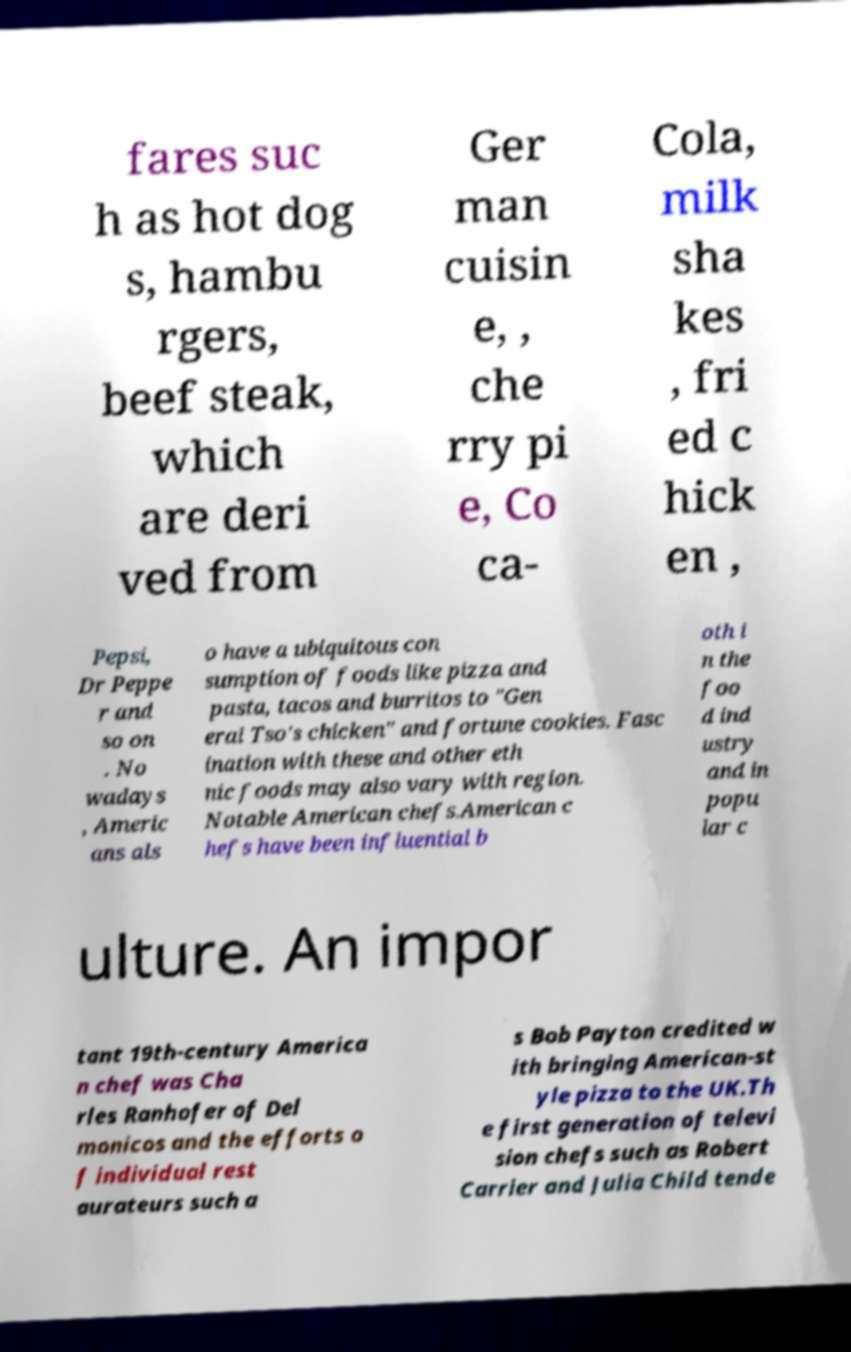Please read and relay the text visible in this image. What does it say? fares suc h as hot dog s, hambu rgers, beef steak, which are deri ved from Ger man cuisin e, , che rry pi e, Co ca- Cola, milk sha kes , fri ed c hick en , Pepsi, Dr Peppe r and so on . No wadays , Americ ans als o have a ubiquitous con sumption of foods like pizza and pasta, tacos and burritos to "Gen eral Tso's chicken" and fortune cookies. Fasc ination with these and other eth nic foods may also vary with region. Notable American chefs.American c hefs have been influential b oth i n the foo d ind ustry and in popu lar c ulture. An impor tant 19th-century America n chef was Cha rles Ranhofer of Del monicos and the efforts o f individual rest aurateurs such a s Bob Payton credited w ith bringing American-st yle pizza to the UK.Th e first generation of televi sion chefs such as Robert Carrier and Julia Child tende 